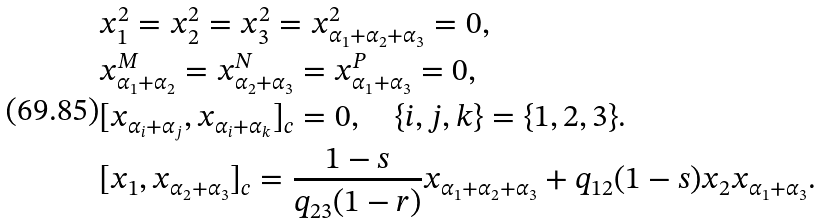<formula> <loc_0><loc_0><loc_500><loc_500>& x _ { 1 } ^ { 2 } = x _ { 2 } ^ { 2 } = x _ { 3 } ^ { 2 } = x _ { \alpha _ { 1 } + \alpha _ { 2 } + \alpha _ { 3 } } ^ { 2 } = 0 , \\ & x _ { \alpha _ { 1 } + \alpha _ { 2 } } ^ { M } = x _ { \alpha _ { 2 } + \alpha _ { 3 } } ^ { N } = x _ { \alpha _ { 1 } + \alpha _ { 3 } } ^ { P } = 0 , \\ & [ x _ { \alpha _ { i } + \alpha _ { j } } , x _ { \alpha _ { i } + \alpha _ { k } } ] _ { c } = 0 , \quad \{ i , j , k \} = \{ 1 , 2 , 3 \} . \\ & [ x _ { 1 } , x _ { \alpha _ { 2 } + \alpha _ { 3 } } ] _ { c } = \frac { 1 - s } { q _ { 2 3 } ( 1 - r ) } x _ { \alpha _ { 1 } + \alpha _ { 2 } + \alpha _ { 3 } } + q _ { 1 2 } ( 1 - s ) x _ { 2 } x _ { \alpha _ { 1 } + \alpha _ { 3 } } .</formula> 